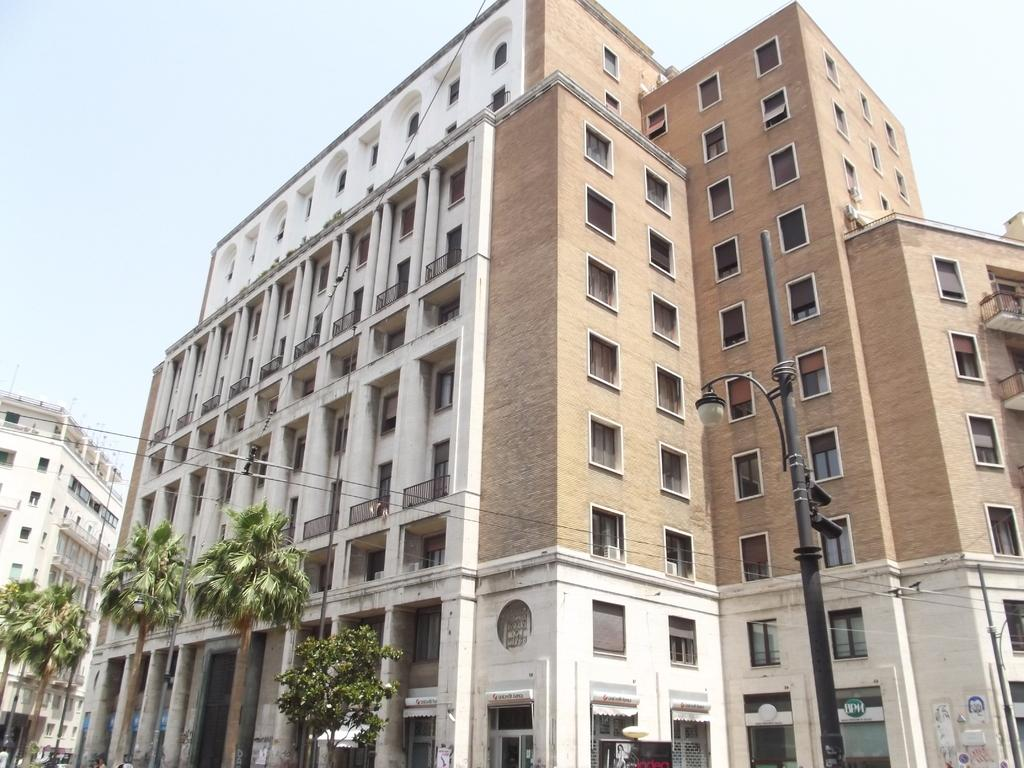What type of structures can be seen in the image? There are buildings in the image. Where is the pole located in the image? The pole is on the right side of the image. What type of vegetation is in front of the buildings? Trees are present in front of the buildings. What is visible in the background of the image? The sky is visible in the background of the image. How many eyes can be seen on the stone in the image? There is no stone or eyes present in the image. 